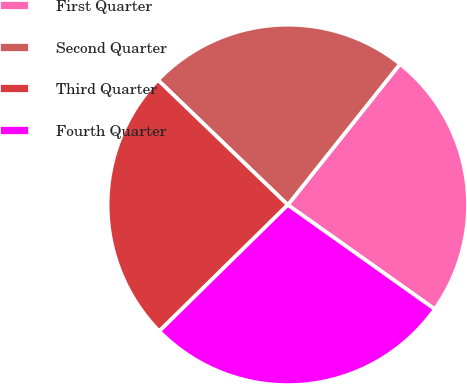Convert chart to OTSL. <chart><loc_0><loc_0><loc_500><loc_500><pie_chart><fcel>First Quarter<fcel>Second Quarter<fcel>Third Quarter<fcel>Fourth Quarter<nl><fcel>24.12%<fcel>23.51%<fcel>24.55%<fcel>27.82%<nl></chart> 